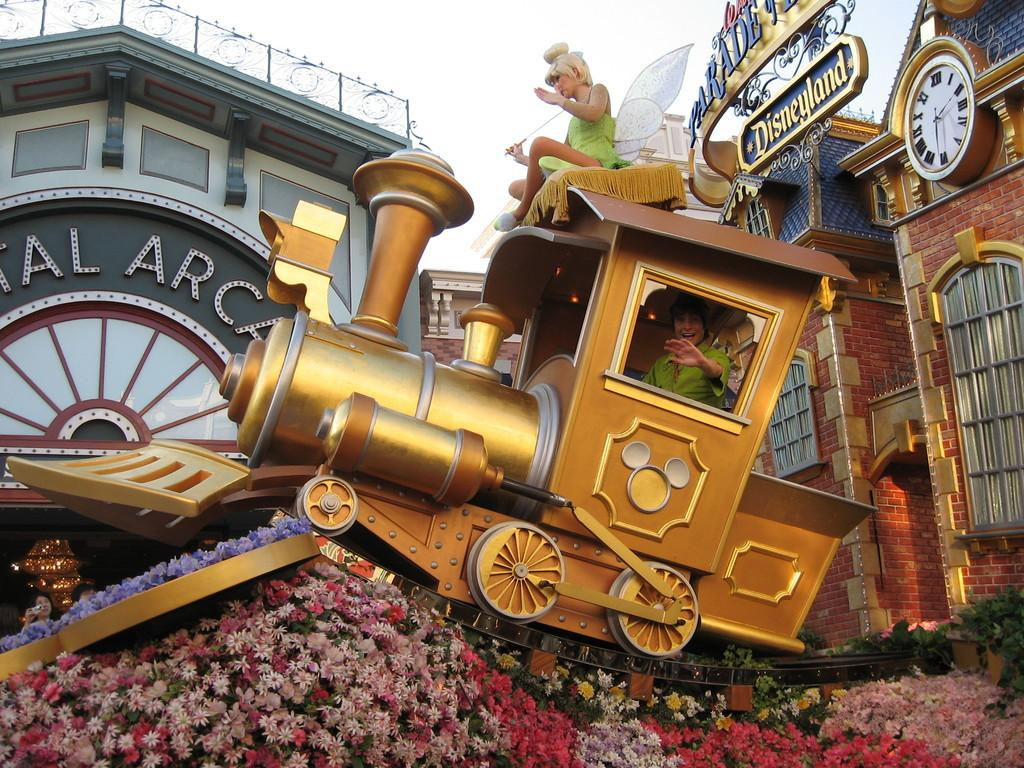<image>
Give a short and clear explanation of the subsequent image. A scene at Disneyland with a flowerbed and a train. 